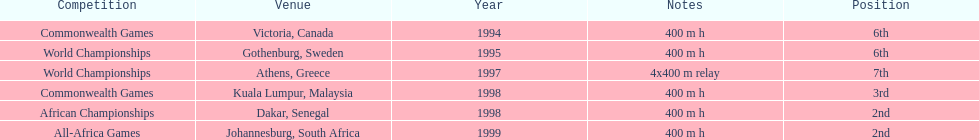What is the final contest on the graph? All-Africa Games. 